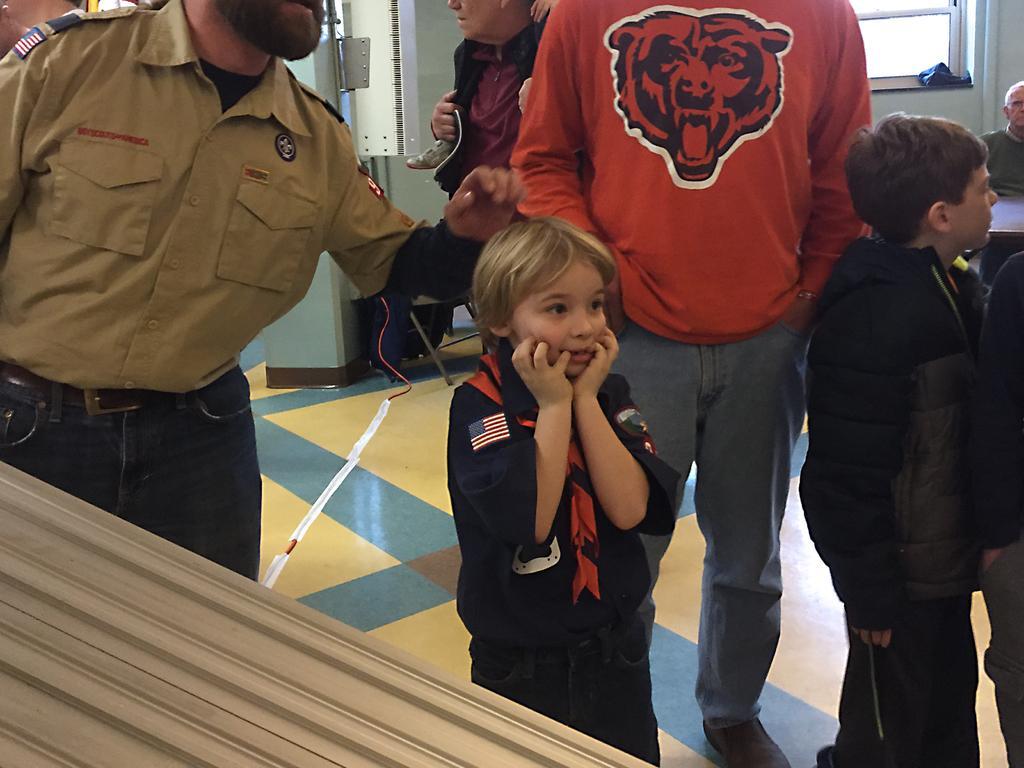In one or two sentences, can you explain what this image depicts? On the right side of the image we can see a person wearing uniform type of dress and standing there. In the middle of the image we can see a person wearing a red color dress and an animal face on the dress is standing there and a boy where he is seeing in the opposite direction. On the right side of the image we can see a person sitting on the chair and a window is there back of him. 